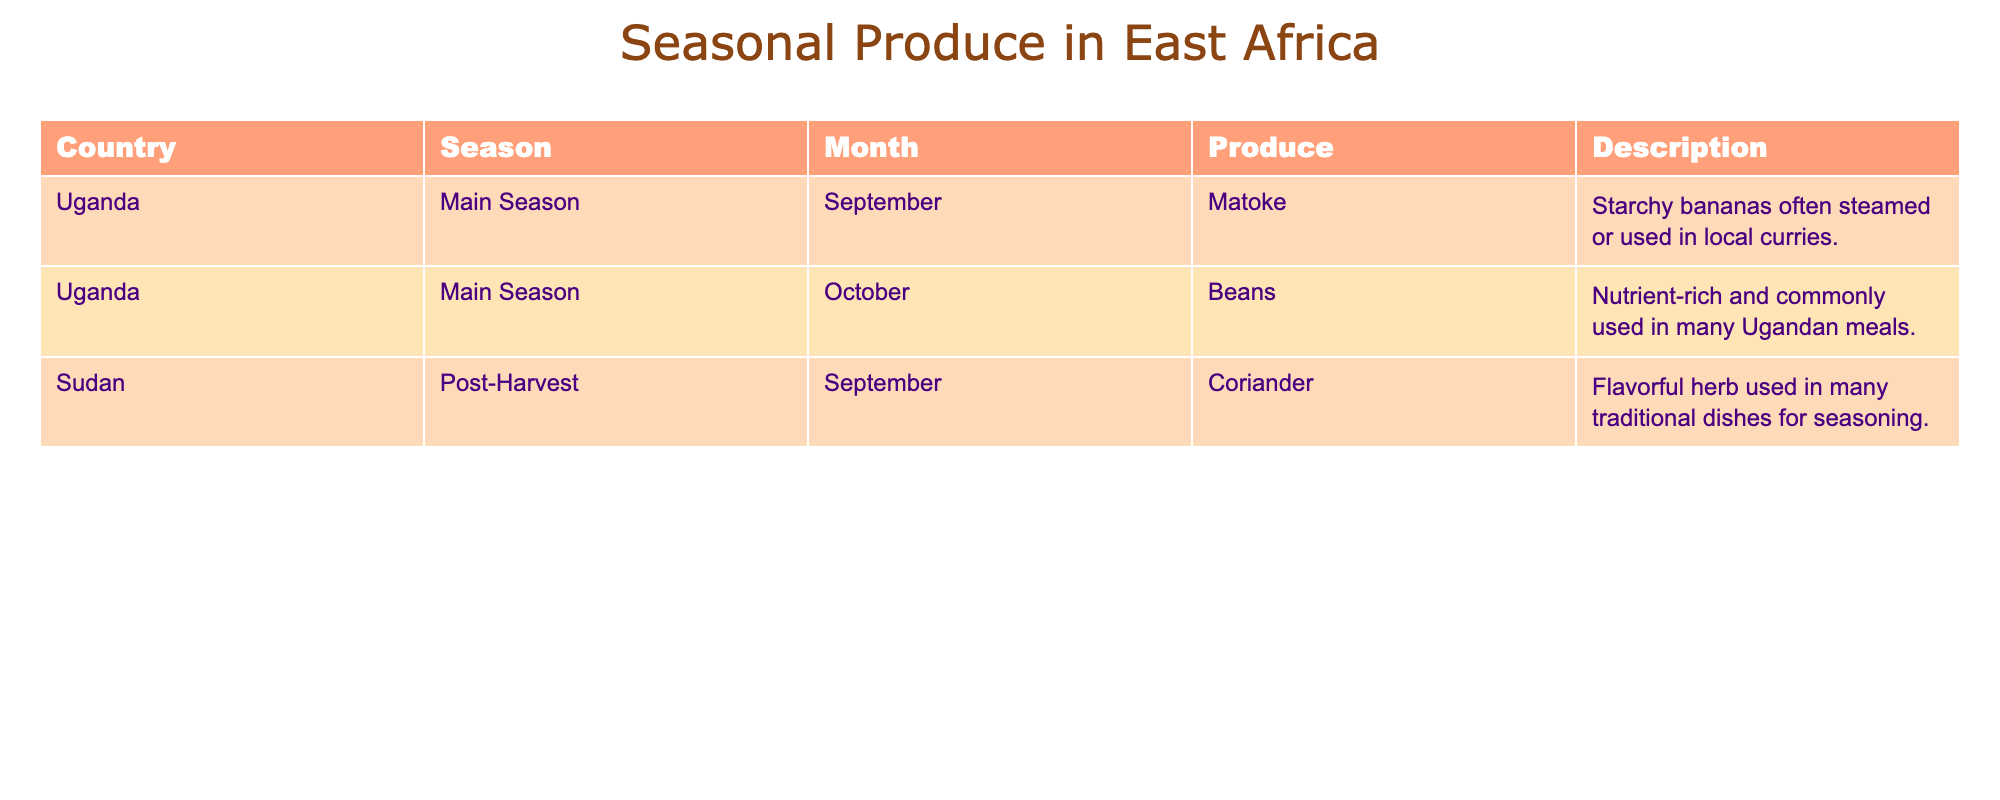What produce is available in Uganda during the main season? The main season for Uganda, as indicated in the table, includes two months: September and October. The listed produce for these months are Matoke in September and Beans in October.
Answer: Matoke and Beans Which herb is produced in Sudan during the post-harvest season? According to the table, the produce available in Sudan during the post-harvest season is Coriander.
Answer: Coriander In which month is Matoke available, and what is it commonly used for? The table shows that Matoke is available in September and is often steamed or used in local curries.
Answer: September, used in local curries Is Beans listed as a seasonal produce in Sudan? The table does not list Beans under Sudan; it specifies Beans only for Uganda. Thus, the answer is no.
Answer: No How many types of produce are listed for Uganda in the main season? The table lists two types of produce for Uganda in the main season: Matoke and Beans.
Answer: 2 Which produce has a description stating it is "nutrient-rich"? The table specifies that Beans is nutrient-rich, as noted in its description for Uganda.
Answer: Beans What season is Coriander associated with in the table, and what does it represent? Coriander is associated with the post-harvest season in Sudan, which signifies a period after the main harvest when certain herbs are available.
Answer: Post-harvest season How does the availability of produce differ between Uganda and Sudan in September? In September, Uganda has Matoke available while Sudan offers Coriander. Therefore, the two countries provide different types of produce in the same month.
Answer: Matoke in Uganda, Coriander in Sudan What is the total number of produce types listed in the table? From the table, there are three distinct types of produce: Matoke, Beans, and Coriander. Adding them gives a total of 3.
Answer: 3 Which country's seasonal produce includes both Matoke and Beans? The table indicates that both Matoke and Beans are seasonal produce in Uganda.
Answer: Uganda 